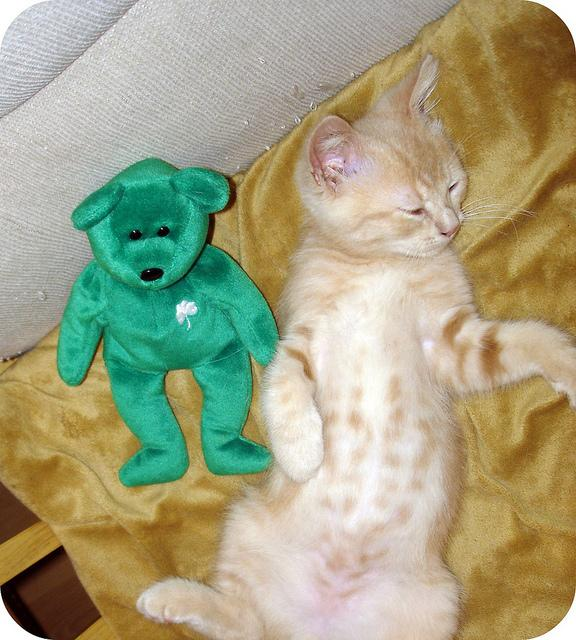What is the logo on the bear? clover 